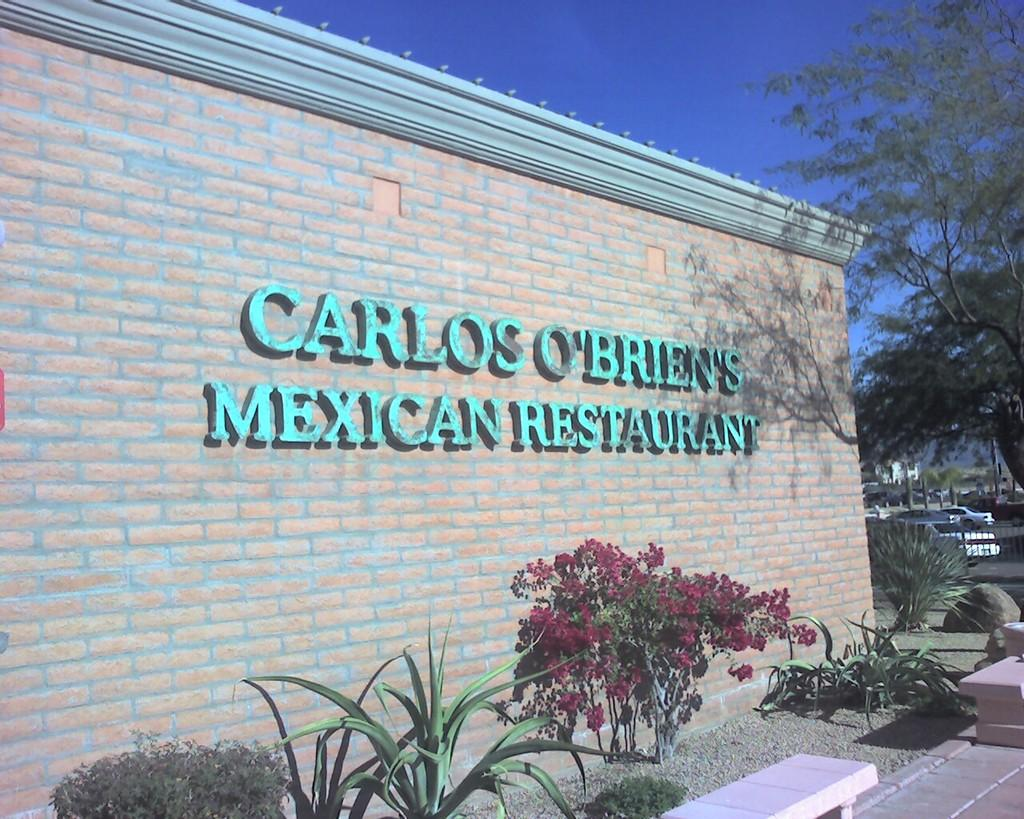What types of living organisms can be seen in the image? Plants, flowers, and trees are visible in the image. What type of seating is available in the image? There are benches in the image. What is the texture of the rock in the image? The rock in the image has a rough texture. What is written on the wall in the image? There is text on a wall in the image. What can be seen in the background of the image? In the background, there is a fence, vehicles, and trees. What is the color of the sky in the background of the image? The sky in the background is blue. Where is the spade used for gardening in the image? There is no spade visible in the image. What type of throne is present in the image? There is no throne present in the image. 